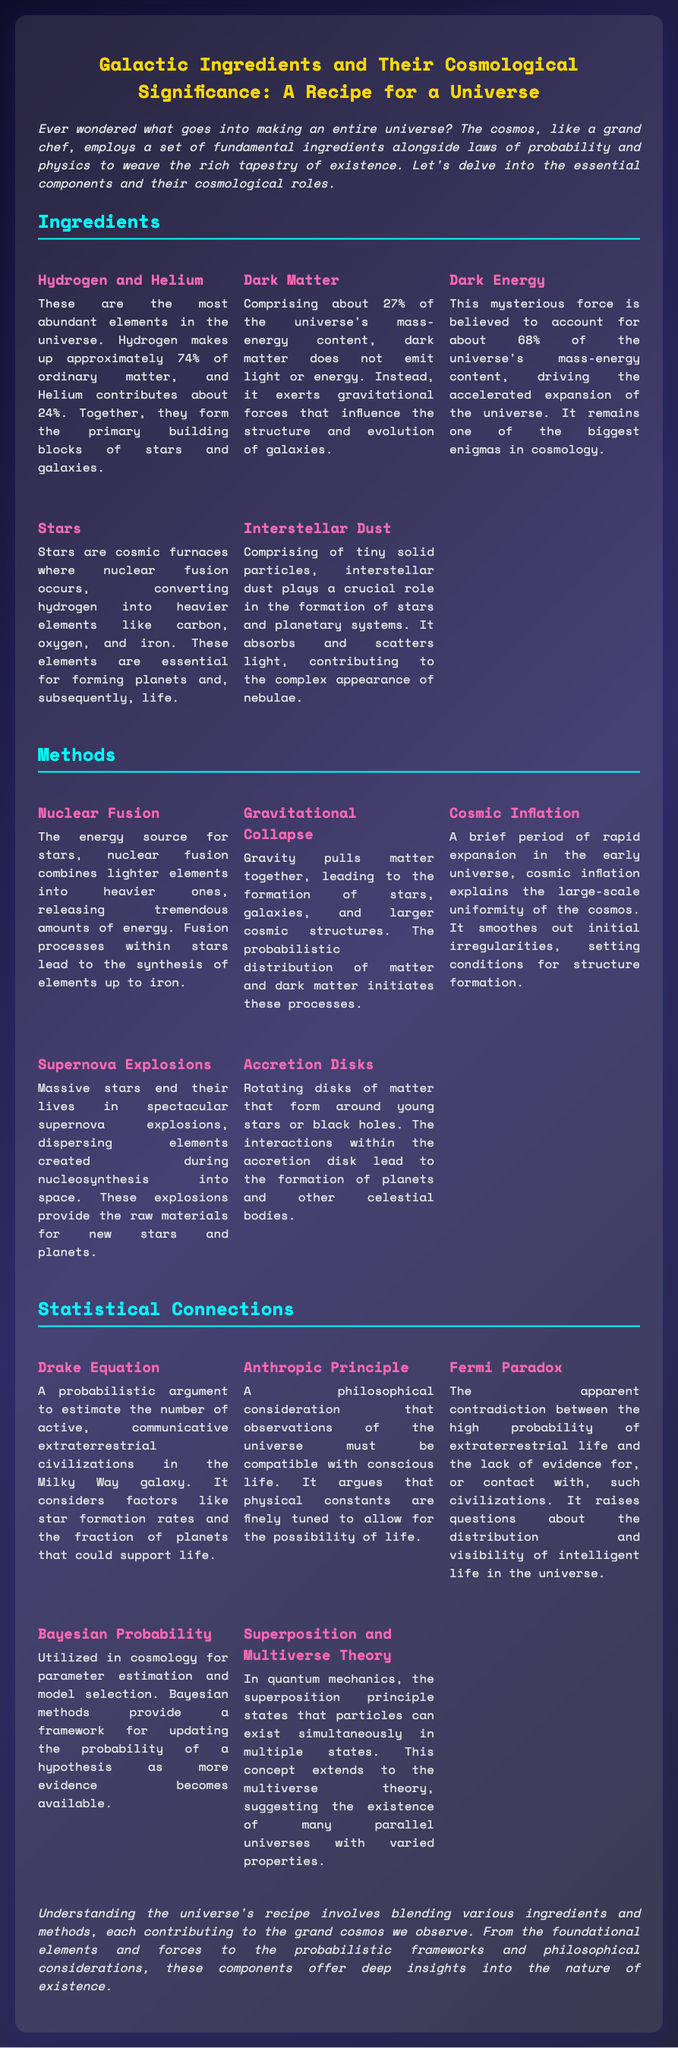What is the main focus of the document? The document discusses the fundamental ingredients and methods used in the creation of the universe and their statistical significance.
Answer: Creation of the universe What percentage of ordinary matter is made up of Hydrogen? The document states that Hydrogen makes up approximately 74% of ordinary matter in the universe.
Answer: 74% What ingredient is believed to account for about 68% of the universe’s mass-energy content? The document indicates that Dark Energy is believed to account for about 68% of the universe's mass-energy content.
Answer: Dark Energy Which method involves the rapid expansion in the early universe? The method referred to in the document that involves rapid expansion is Cosmic Inflation.
Answer: Cosmic Inflation What statistical concept estimates the number of communicative extraterrestrial civilizations? The Drake Equation is used to estimate the number of active, communicative extraterrestrial civilizations in the Milky Way galaxy.
Answer: Drake Equation What role does interstellar dust play in the cosmos? Interstellar dust plays a crucial role in the formation of stars and planetary systems.
Answer: Formation of stars What does the Fermi Paradox question? The Fermi Paradox questions the contradiction between the high probability of extraterrestrial life and the lack of evidence for such civilizations.
Answer: Extraterrestrial life What is a crucial method of nuclear fission? Nuclear Fusion combines lighter elements into heavier ones, releasing tremendous amounts of energy.
Answer: Nuclear Fusion What is the document's aesthetic style inspired by? The document's design uses cosmic themes, reflected in its space-inspired font and color scheme.
Answer: Cosmic themes 